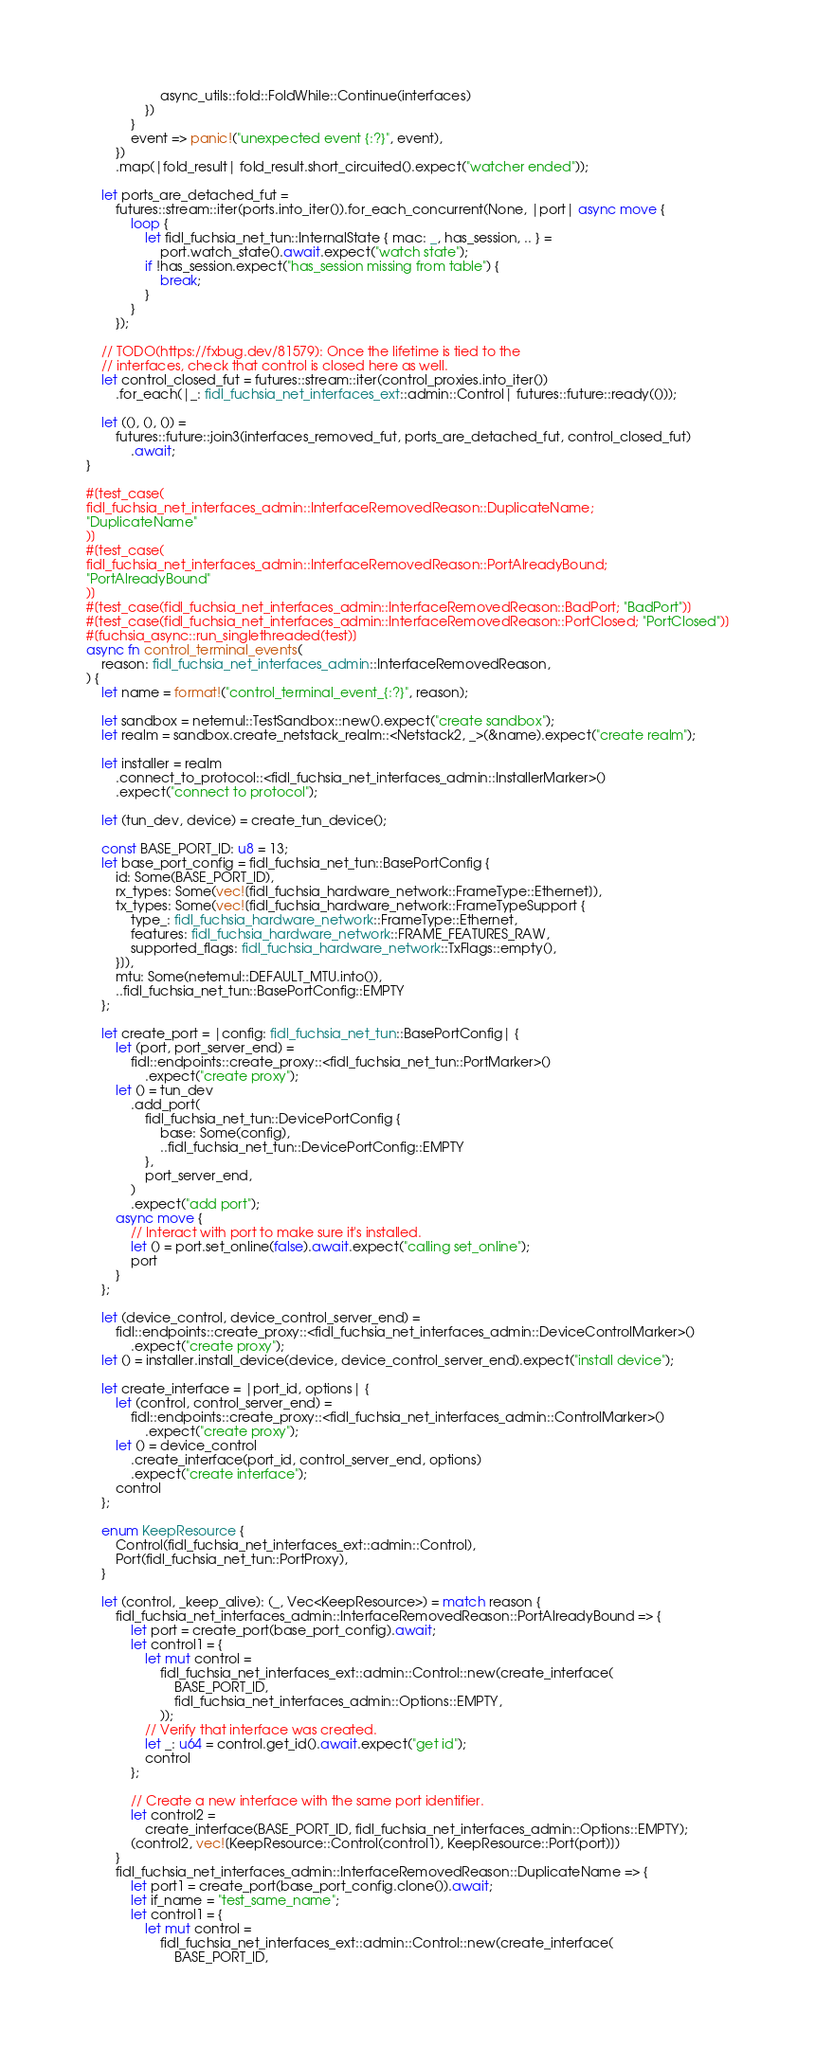<code> <loc_0><loc_0><loc_500><loc_500><_Rust_>                    async_utils::fold::FoldWhile::Continue(interfaces)
                })
            }
            event => panic!("unexpected event {:?}", event),
        })
        .map(|fold_result| fold_result.short_circuited().expect("watcher ended"));

    let ports_are_detached_fut =
        futures::stream::iter(ports.into_iter()).for_each_concurrent(None, |port| async move {
            loop {
                let fidl_fuchsia_net_tun::InternalState { mac: _, has_session, .. } =
                    port.watch_state().await.expect("watch state");
                if !has_session.expect("has_session missing from table") {
                    break;
                }
            }
        });

    // TODO(https://fxbug.dev/81579): Once the lifetime is tied to the
    // interfaces, check that control is closed here as well.
    let control_closed_fut = futures::stream::iter(control_proxies.into_iter())
        .for_each(|_: fidl_fuchsia_net_interfaces_ext::admin::Control| futures::future::ready(()));

    let ((), (), ()) =
        futures::future::join3(interfaces_removed_fut, ports_are_detached_fut, control_closed_fut)
            .await;
}

#[test_case(
fidl_fuchsia_net_interfaces_admin::InterfaceRemovedReason::DuplicateName;
"DuplicateName"
)]
#[test_case(
fidl_fuchsia_net_interfaces_admin::InterfaceRemovedReason::PortAlreadyBound;
"PortAlreadyBound"
)]
#[test_case(fidl_fuchsia_net_interfaces_admin::InterfaceRemovedReason::BadPort; "BadPort")]
#[test_case(fidl_fuchsia_net_interfaces_admin::InterfaceRemovedReason::PortClosed; "PortClosed")]
#[fuchsia_async::run_singlethreaded(test)]
async fn control_terminal_events(
    reason: fidl_fuchsia_net_interfaces_admin::InterfaceRemovedReason,
) {
    let name = format!("control_terminal_event_{:?}", reason);

    let sandbox = netemul::TestSandbox::new().expect("create sandbox");
    let realm = sandbox.create_netstack_realm::<Netstack2, _>(&name).expect("create realm");

    let installer = realm
        .connect_to_protocol::<fidl_fuchsia_net_interfaces_admin::InstallerMarker>()
        .expect("connect to protocol");

    let (tun_dev, device) = create_tun_device();

    const BASE_PORT_ID: u8 = 13;
    let base_port_config = fidl_fuchsia_net_tun::BasePortConfig {
        id: Some(BASE_PORT_ID),
        rx_types: Some(vec![fidl_fuchsia_hardware_network::FrameType::Ethernet]),
        tx_types: Some(vec![fidl_fuchsia_hardware_network::FrameTypeSupport {
            type_: fidl_fuchsia_hardware_network::FrameType::Ethernet,
            features: fidl_fuchsia_hardware_network::FRAME_FEATURES_RAW,
            supported_flags: fidl_fuchsia_hardware_network::TxFlags::empty(),
        }]),
        mtu: Some(netemul::DEFAULT_MTU.into()),
        ..fidl_fuchsia_net_tun::BasePortConfig::EMPTY
    };

    let create_port = |config: fidl_fuchsia_net_tun::BasePortConfig| {
        let (port, port_server_end) =
            fidl::endpoints::create_proxy::<fidl_fuchsia_net_tun::PortMarker>()
                .expect("create proxy");
        let () = tun_dev
            .add_port(
                fidl_fuchsia_net_tun::DevicePortConfig {
                    base: Some(config),
                    ..fidl_fuchsia_net_tun::DevicePortConfig::EMPTY
                },
                port_server_end,
            )
            .expect("add port");
        async move {
            // Interact with port to make sure it's installed.
            let () = port.set_online(false).await.expect("calling set_online");
            port
        }
    };

    let (device_control, device_control_server_end) =
        fidl::endpoints::create_proxy::<fidl_fuchsia_net_interfaces_admin::DeviceControlMarker>()
            .expect("create proxy");
    let () = installer.install_device(device, device_control_server_end).expect("install device");

    let create_interface = |port_id, options| {
        let (control, control_server_end) =
            fidl::endpoints::create_proxy::<fidl_fuchsia_net_interfaces_admin::ControlMarker>()
                .expect("create proxy");
        let () = device_control
            .create_interface(port_id, control_server_end, options)
            .expect("create interface");
        control
    };

    enum KeepResource {
        Control(fidl_fuchsia_net_interfaces_ext::admin::Control),
        Port(fidl_fuchsia_net_tun::PortProxy),
    }

    let (control, _keep_alive): (_, Vec<KeepResource>) = match reason {
        fidl_fuchsia_net_interfaces_admin::InterfaceRemovedReason::PortAlreadyBound => {
            let port = create_port(base_port_config).await;
            let control1 = {
                let mut control =
                    fidl_fuchsia_net_interfaces_ext::admin::Control::new(create_interface(
                        BASE_PORT_ID,
                        fidl_fuchsia_net_interfaces_admin::Options::EMPTY,
                    ));
                // Verify that interface was created.
                let _: u64 = control.get_id().await.expect("get id");
                control
            };

            // Create a new interface with the same port identifier.
            let control2 =
                create_interface(BASE_PORT_ID, fidl_fuchsia_net_interfaces_admin::Options::EMPTY);
            (control2, vec![KeepResource::Control(control1), KeepResource::Port(port)])
        }
        fidl_fuchsia_net_interfaces_admin::InterfaceRemovedReason::DuplicateName => {
            let port1 = create_port(base_port_config.clone()).await;
            let if_name = "test_same_name";
            let control1 = {
                let mut control =
                    fidl_fuchsia_net_interfaces_ext::admin::Control::new(create_interface(
                        BASE_PORT_ID,</code> 